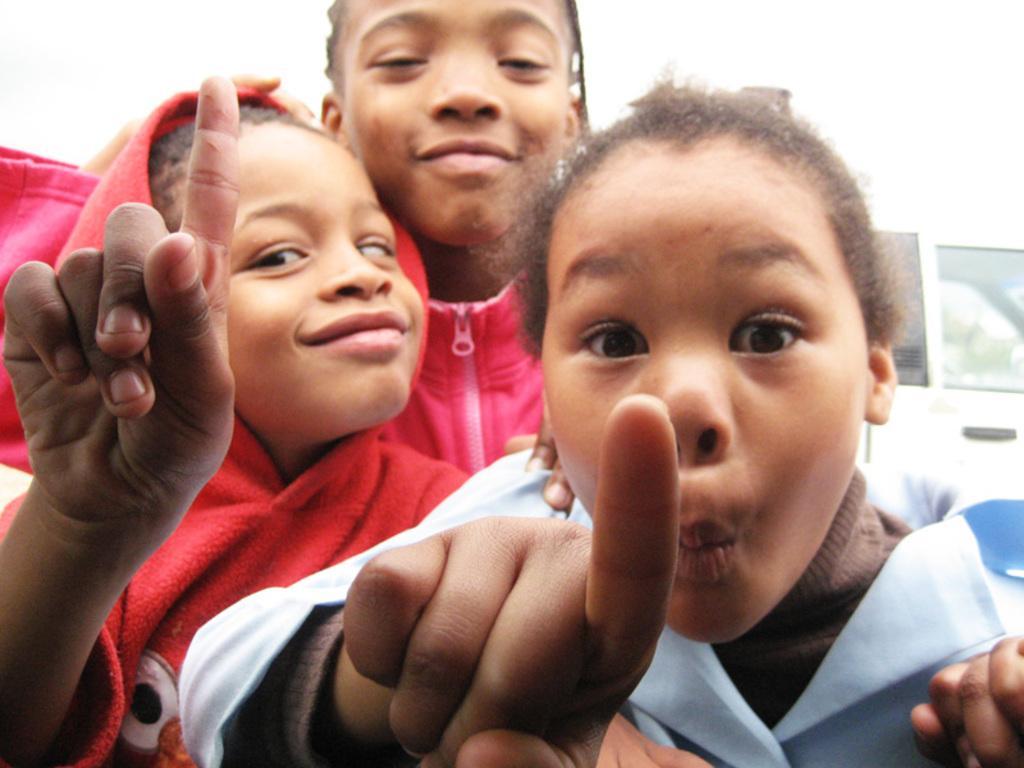How would you summarize this image in a sentence or two? In the picture there are three kids,three of them are giving weird expressions and two of the kids are pointing their fingers and in the background there is a wall. 